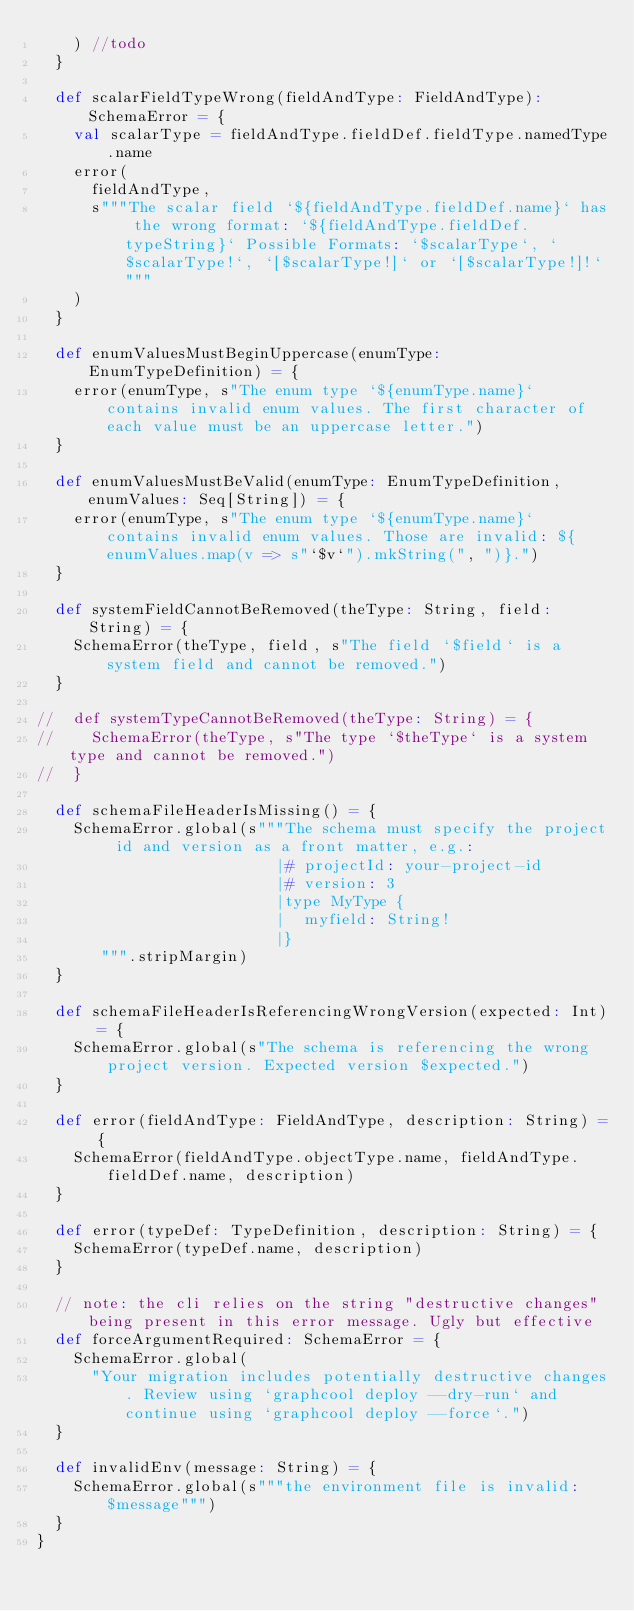<code> <loc_0><loc_0><loc_500><loc_500><_Scala_>    ) //todo
  }

  def scalarFieldTypeWrong(fieldAndType: FieldAndType): SchemaError = {
    val scalarType = fieldAndType.fieldDef.fieldType.namedType.name
    error(
      fieldAndType,
      s"""The scalar field `${fieldAndType.fieldDef.name}` has the wrong format: `${fieldAndType.fieldDef.typeString}` Possible Formats: `$scalarType`, `$scalarType!`, `[$scalarType!]` or `[$scalarType!]!`"""
    )
  }

  def enumValuesMustBeginUppercase(enumType: EnumTypeDefinition) = {
    error(enumType, s"The enum type `${enumType.name}` contains invalid enum values. The first character of each value must be an uppercase letter.")
  }

  def enumValuesMustBeValid(enumType: EnumTypeDefinition, enumValues: Seq[String]) = {
    error(enumType, s"The enum type `${enumType.name}` contains invalid enum values. Those are invalid: ${enumValues.map(v => s"`$v`").mkString(", ")}.")
  }

  def systemFieldCannotBeRemoved(theType: String, field: String) = {
    SchemaError(theType, field, s"The field `$field` is a system field and cannot be removed.")
  }

//  def systemTypeCannotBeRemoved(theType: String) = {
//    SchemaError(theType, s"The type `$theType` is a system type and cannot be removed.")
//  }

  def schemaFileHeaderIsMissing() = {
    SchemaError.global(s"""The schema must specify the project id and version as a front matter, e.g.:
                          |# projectId: your-project-id
                          |# version: 3
                          |type MyType {
                          |  myfield: String!
                          |}
       """.stripMargin)
  }

  def schemaFileHeaderIsReferencingWrongVersion(expected: Int) = {
    SchemaError.global(s"The schema is referencing the wrong project version. Expected version $expected.")
  }

  def error(fieldAndType: FieldAndType, description: String) = {
    SchemaError(fieldAndType.objectType.name, fieldAndType.fieldDef.name, description)
  }

  def error(typeDef: TypeDefinition, description: String) = {
    SchemaError(typeDef.name, description)
  }

  // note: the cli relies on the string "destructive changes" being present in this error message. Ugly but effective
  def forceArgumentRequired: SchemaError = {
    SchemaError.global(
      "Your migration includes potentially destructive changes. Review using `graphcool deploy --dry-run` and continue using `graphcool deploy --force`.")
  }

  def invalidEnv(message: String) = {
    SchemaError.global(s"""the environment file is invalid: $message""")
  }
}
</code> 